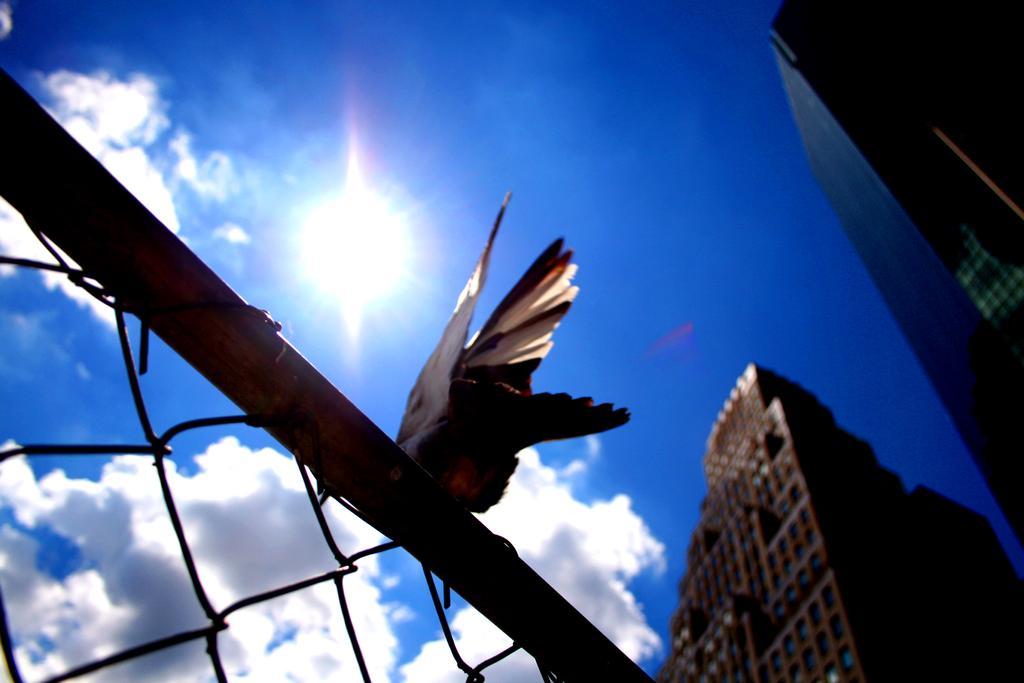In one or two sentences, can you explain what this image depicts? In this image I can see a bird which is black and white in color on the metal rod and I can see the metal fencing. In the background I can see few buildings and the sky. 